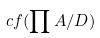<formula> <loc_0><loc_0><loc_500><loc_500>c f ( \prod A / D )</formula> 